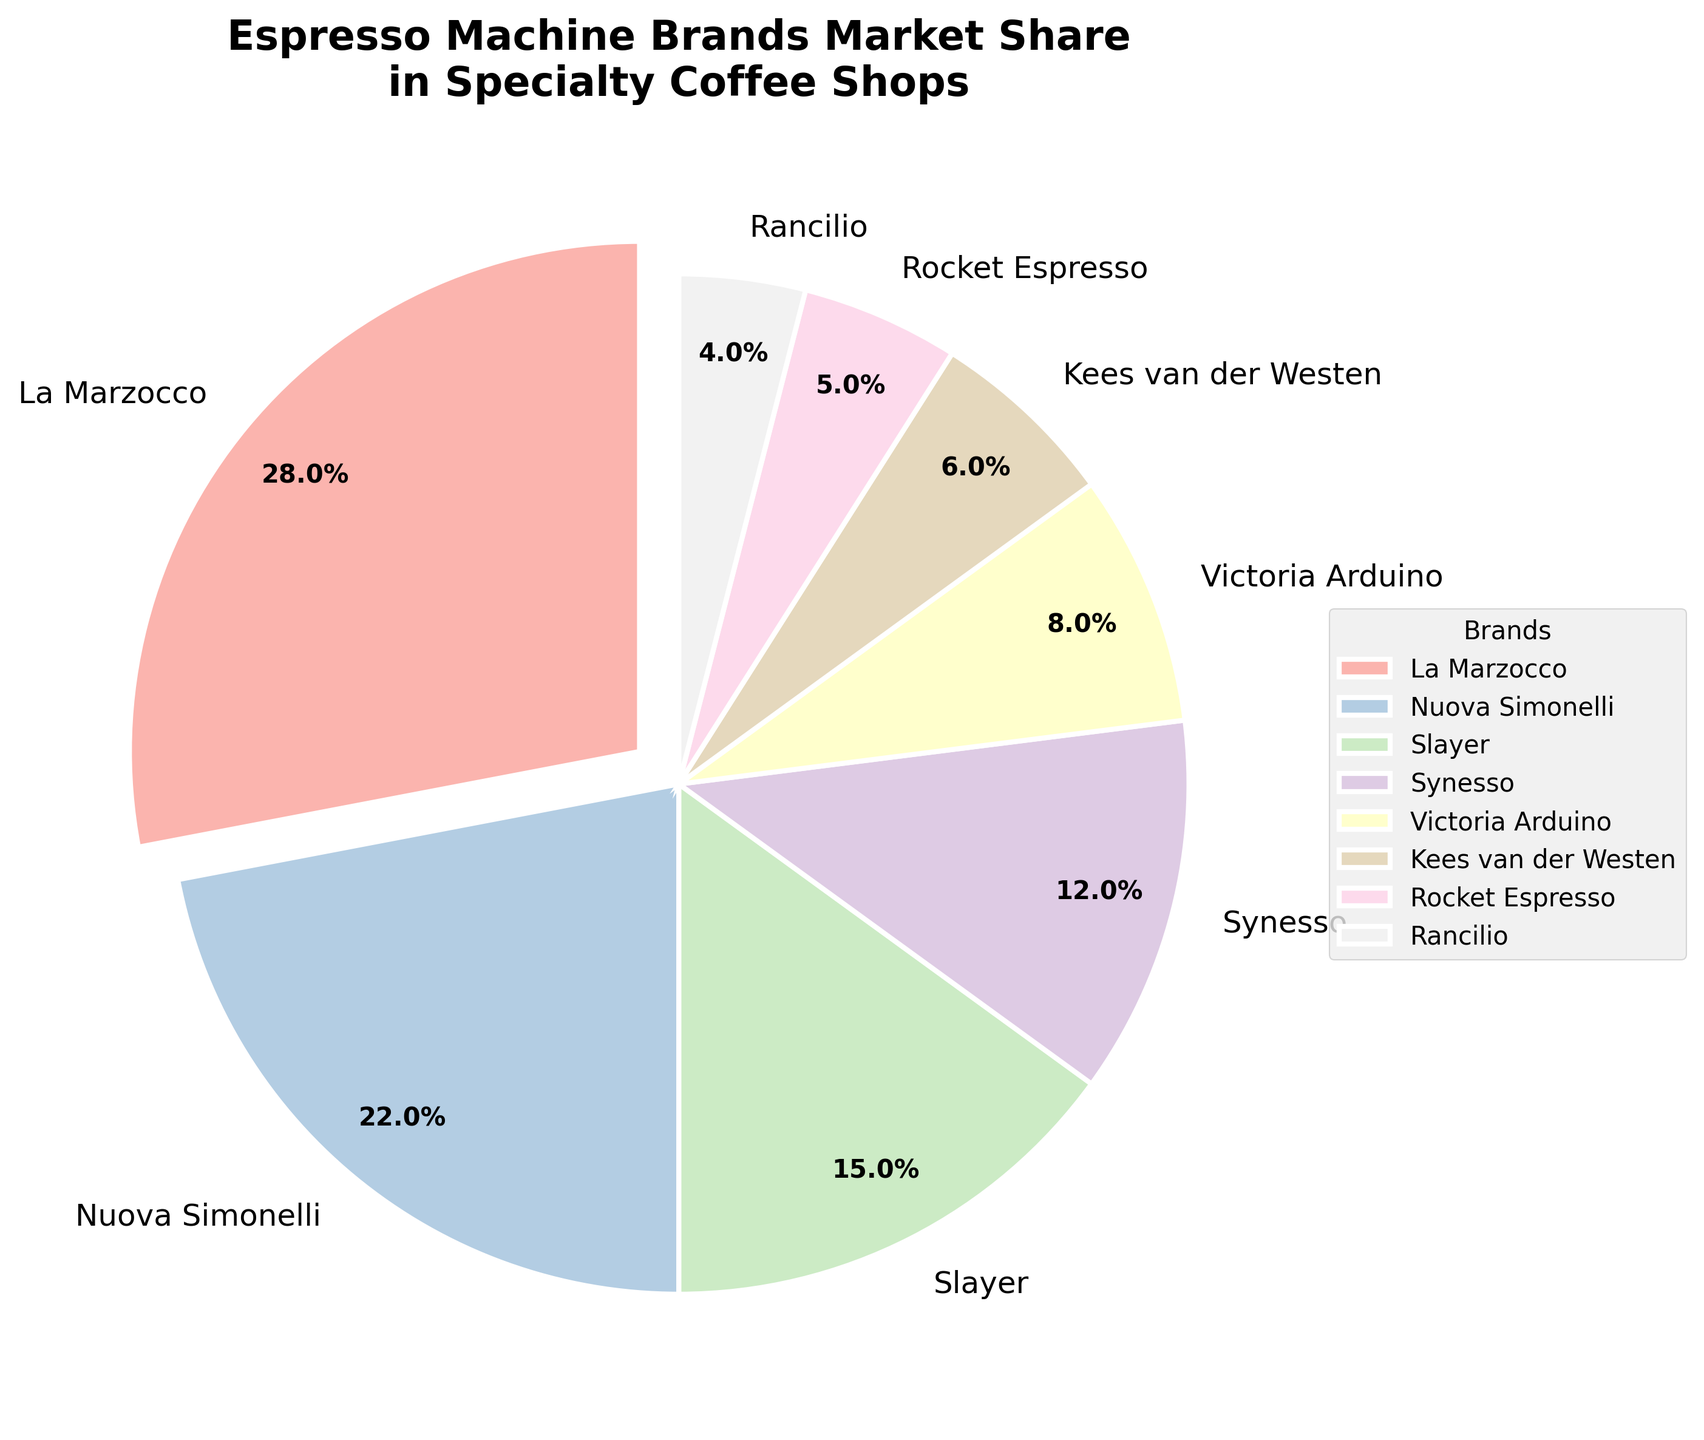Which brand has the largest market share? By looking at the pie chart, observe the brand with the largest wedge or the slice that is "exploded" out of the pie.
Answer: La Marzocco What is the combined market share of Synesso and Slayer? Locate the percentage for Synesso (12%) and Slayer (15%) on the pie chart and sum them up.
Answer: 27% Which brand has a larger market share, Rocket Espresso or Rancilio? Identify the wedges for Rocket Espresso (5%) and Rancilio (4%) and compare their values.
Answer: Rocket Espresso How much greater is La Marzocco's market share compared to Nuova Simonelli? Find the market share of La Marzocco (28%) and Nuova Simonelli (22%) and subtract the smaller value from the larger value (28% - 22%).
Answer: 6% What is the total market share of the brands with less than 10% each? Identify the brands with less than 10%—Victoria Arduino (8%), Kees van der Westen (6%), Rocket Espresso (5%), and Rancilio (4%)—and sum their market shares (8% + 6% + 5% + 4%).
Answer: 23% Which brand's wedge is shown in the darkest shade in the chart? Observe the visual coloration of the wedges to find the darkest shade.
Answer: La Marzocco If you combine the market shares of the top three brands, what percentage do they hold together? Sum the market shares of La Marzocco (28%), Nuova Simonelli (22%), and Slayer (15%) (28% + 22% + 15%).
Answer: 65% What is the difference in market share between the brand with the smallest wedge and Kees van der Westen? Find the market shares of Rocket Espresso (5%) and Rancilio (4%), identify the smallest (Rancilio), and subtract it from Kees van der Westen's market share (6% - 4%).
Answer: 2% Which brands have market shares represented by wedges in pastel colors? In the pie chart using pastel colors, identify all labeled brand wedges. Note that all brands are represented in such colors.
Answer: All brands 